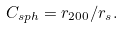Convert formula to latex. <formula><loc_0><loc_0><loc_500><loc_500>C _ { s p h } = r _ { 2 0 0 } / r _ { s } .</formula> 